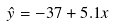Convert formula to latex. <formula><loc_0><loc_0><loc_500><loc_500>\hat { y } = - 3 7 + 5 . 1 x</formula> 